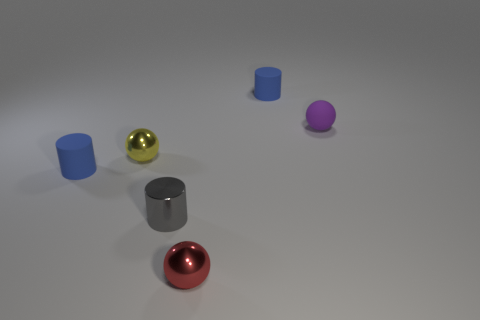Add 4 purple objects. How many objects exist? 10 Add 1 small red metallic balls. How many small red metallic balls are left? 2 Add 4 tiny purple rubber balls. How many tiny purple rubber balls exist? 5 Subtract 1 yellow spheres. How many objects are left? 5 Subtract all blue rubber things. Subtract all gray objects. How many objects are left? 3 